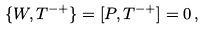<formula> <loc_0><loc_0><loc_500><loc_500>\{ W , T ^ { - + } \} = [ P , T ^ { - + } ] = 0 \, ,</formula> 